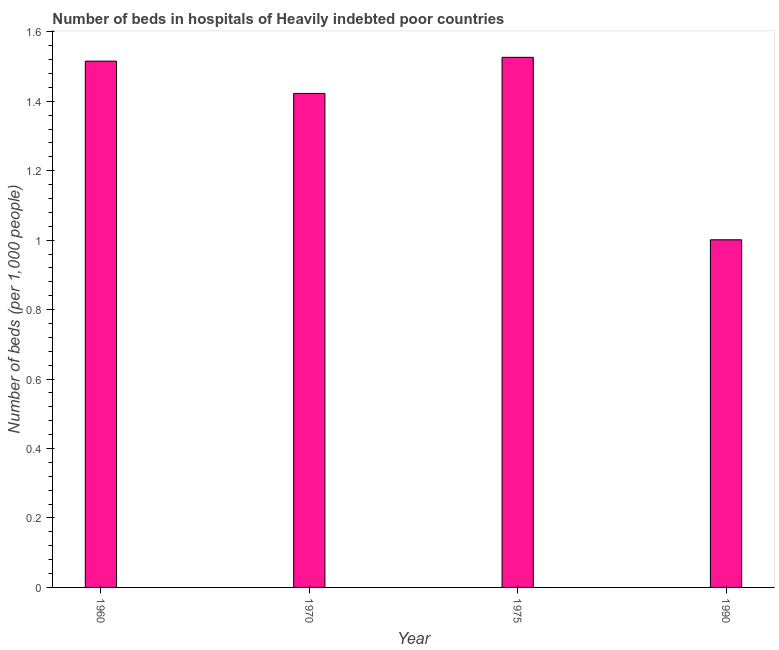What is the title of the graph?
Offer a terse response. Number of beds in hospitals of Heavily indebted poor countries. What is the label or title of the Y-axis?
Your answer should be very brief. Number of beds (per 1,0 people). What is the number of hospital beds in 1970?
Offer a very short reply. 1.42. Across all years, what is the maximum number of hospital beds?
Offer a very short reply. 1.53. Across all years, what is the minimum number of hospital beds?
Your response must be concise. 1. In which year was the number of hospital beds maximum?
Offer a very short reply. 1975. In which year was the number of hospital beds minimum?
Offer a terse response. 1990. What is the sum of the number of hospital beds?
Provide a succinct answer. 5.47. What is the difference between the number of hospital beds in 1970 and 1990?
Keep it short and to the point. 0.42. What is the average number of hospital beds per year?
Your answer should be compact. 1.37. What is the median number of hospital beds?
Give a very brief answer. 1.47. In how many years, is the number of hospital beds greater than 1.24 %?
Your answer should be compact. 3. What is the ratio of the number of hospital beds in 1970 to that in 1975?
Provide a short and direct response. 0.93. Is the difference between the number of hospital beds in 1970 and 1990 greater than the difference between any two years?
Provide a succinct answer. No. What is the difference between the highest and the second highest number of hospital beds?
Your answer should be very brief. 0.01. What is the difference between the highest and the lowest number of hospital beds?
Your response must be concise. 0.53. Are all the bars in the graph horizontal?
Provide a short and direct response. No. Are the values on the major ticks of Y-axis written in scientific E-notation?
Offer a terse response. No. What is the Number of beds (per 1,000 people) of 1960?
Offer a very short reply. 1.52. What is the Number of beds (per 1,000 people) of 1970?
Offer a terse response. 1.42. What is the Number of beds (per 1,000 people) in 1975?
Your answer should be very brief. 1.53. What is the Number of beds (per 1,000 people) of 1990?
Offer a very short reply. 1. What is the difference between the Number of beds (per 1,000 people) in 1960 and 1970?
Offer a terse response. 0.09. What is the difference between the Number of beds (per 1,000 people) in 1960 and 1975?
Your answer should be compact. -0.01. What is the difference between the Number of beds (per 1,000 people) in 1960 and 1990?
Give a very brief answer. 0.51. What is the difference between the Number of beds (per 1,000 people) in 1970 and 1975?
Your response must be concise. -0.1. What is the difference between the Number of beds (per 1,000 people) in 1970 and 1990?
Provide a short and direct response. 0.42. What is the difference between the Number of beds (per 1,000 people) in 1975 and 1990?
Your answer should be very brief. 0.53. What is the ratio of the Number of beds (per 1,000 people) in 1960 to that in 1970?
Your response must be concise. 1.06. What is the ratio of the Number of beds (per 1,000 people) in 1960 to that in 1990?
Provide a succinct answer. 1.51. What is the ratio of the Number of beds (per 1,000 people) in 1970 to that in 1975?
Ensure brevity in your answer.  0.93. What is the ratio of the Number of beds (per 1,000 people) in 1970 to that in 1990?
Offer a very short reply. 1.42. What is the ratio of the Number of beds (per 1,000 people) in 1975 to that in 1990?
Provide a short and direct response. 1.52. 